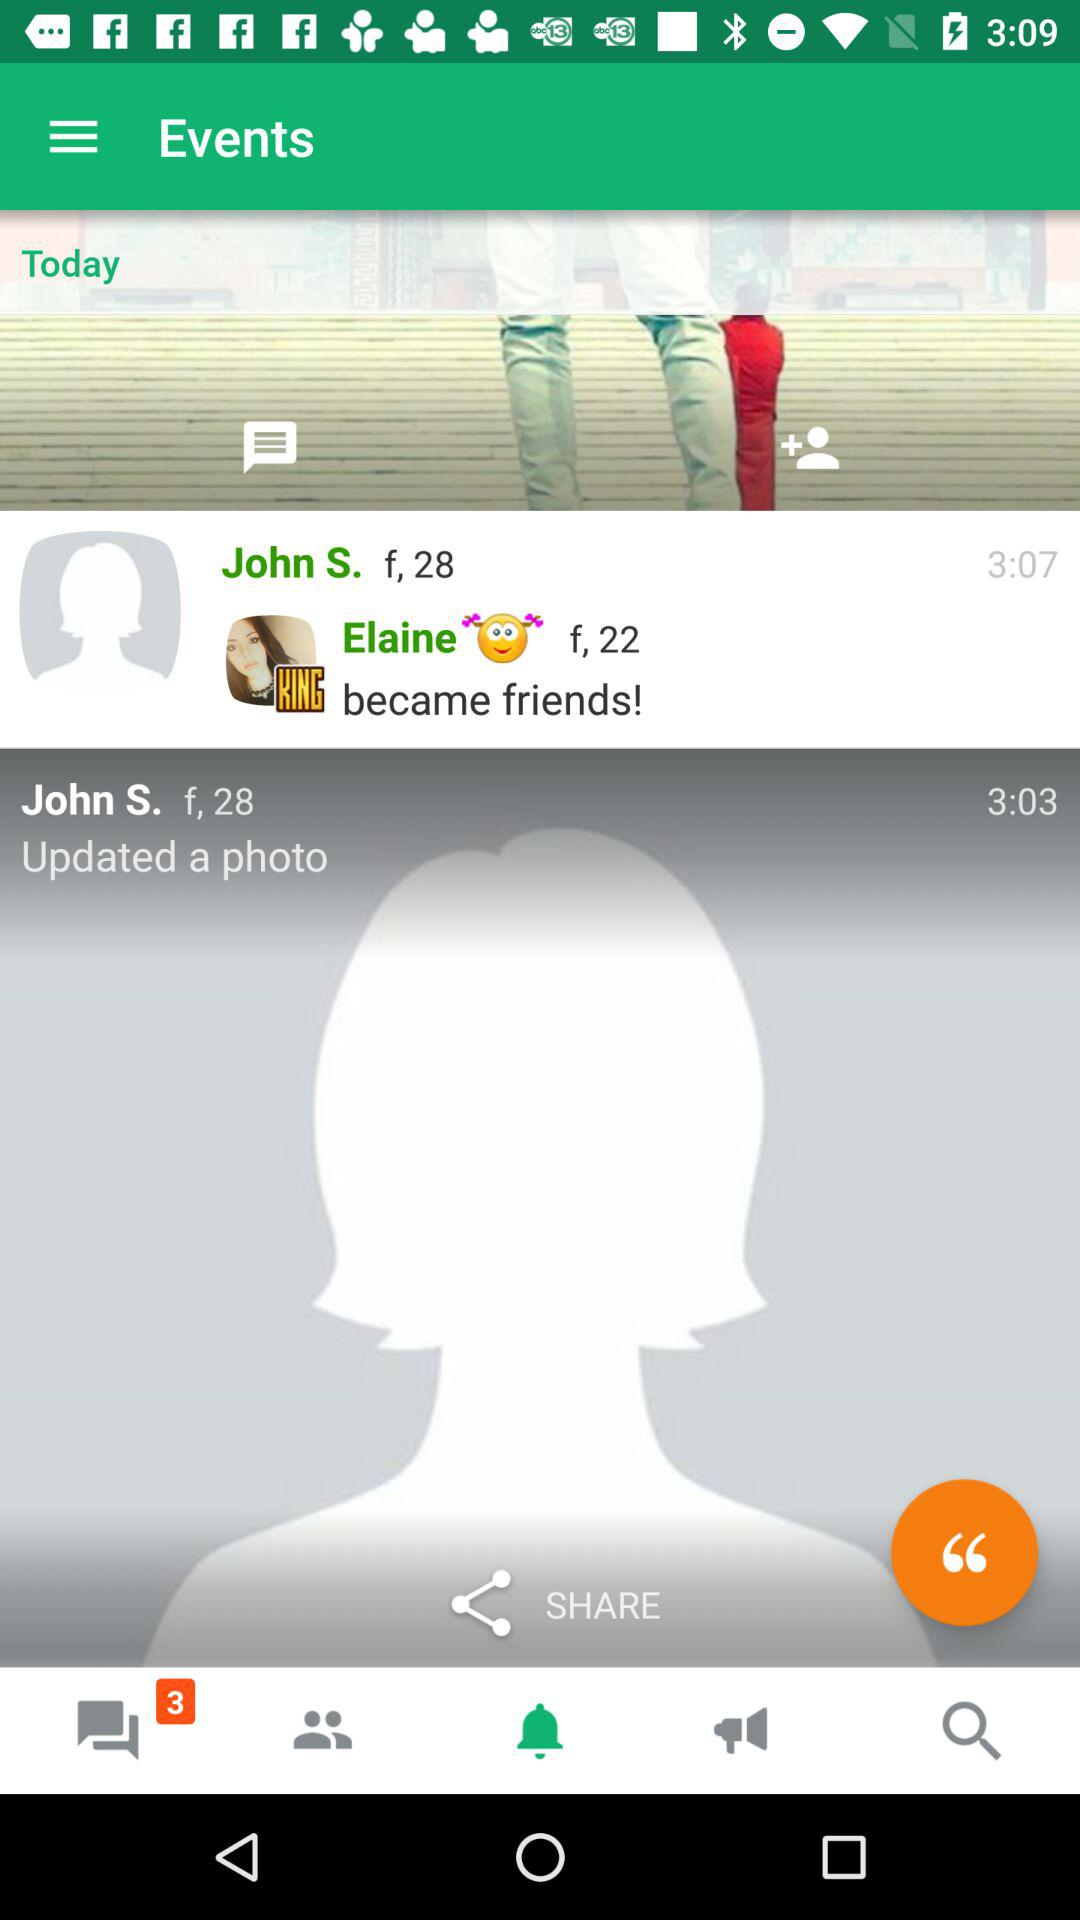Is there any unread chat?
When the provided information is insufficient, respond with <no answer>. <no answer> 